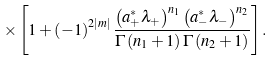<formula> <loc_0><loc_0><loc_500><loc_500>\times \left [ 1 + \left ( - 1 \right ) ^ { 2 \left | m \right | } \frac { \left ( a _ { + } ^ { \ast } \lambda _ { + } \right ) ^ { n _ { 1 } } \left ( a _ { - } ^ { \ast } \lambda _ { - } \right ) ^ { n _ { 2 } } } { \Gamma \left ( n _ { 1 } + 1 \right ) \Gamma \left ( n _ { 2 } + 1 \right ) } \right ] .</formula> 